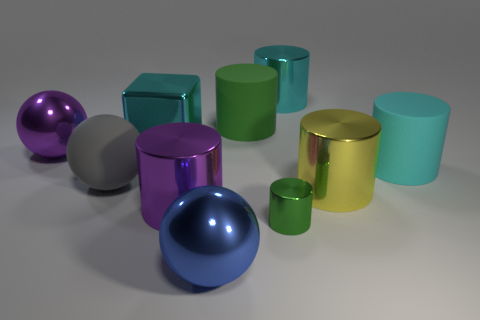Subtract all purple metallic cylinders. How many cylinders are left? 5 Subtract all green cylinders. How many cylinders are left? 4 Add 6 large cyan shiny objects. How many large cyan shiny objects are left? 8 Add 9 big gray spheres. How many big gray spheres exist? 10 Subtract 1 gray balls. How many objects are left? 9 Subtract all cylinders. How many objects are left? 4 Subtract 1 cubes. How many cubes are left? 0 Subtract all green cylinders. Subtract all cyan balls. How many cylinders are left? 4 Subtract all cyan spheres. How many green cylinders are left? 2 Subtract all big rubber balls. Subtract all large cyan rubber cylinders. How many objects are left? 8 